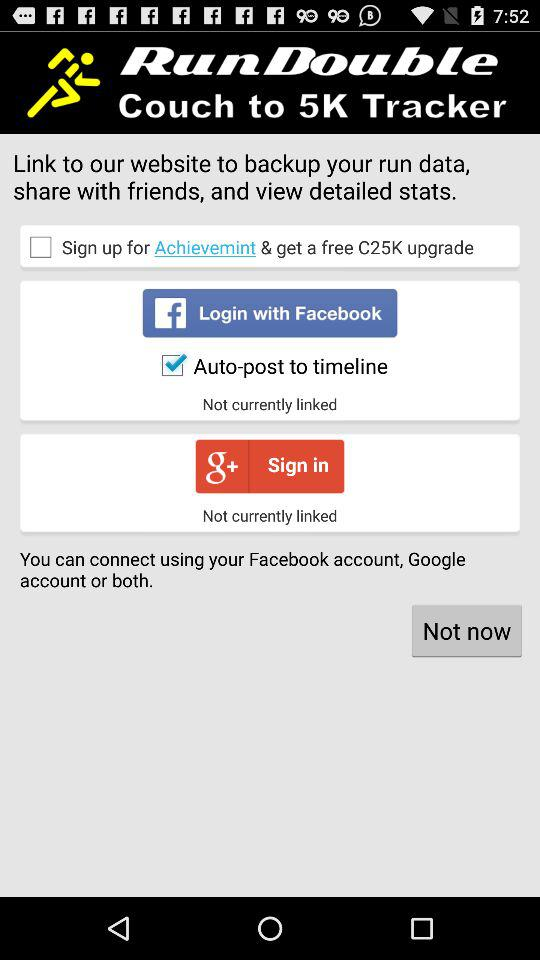Is "Auto-post to timeline" checked or not? "Auto-post to timeline" is checked. 